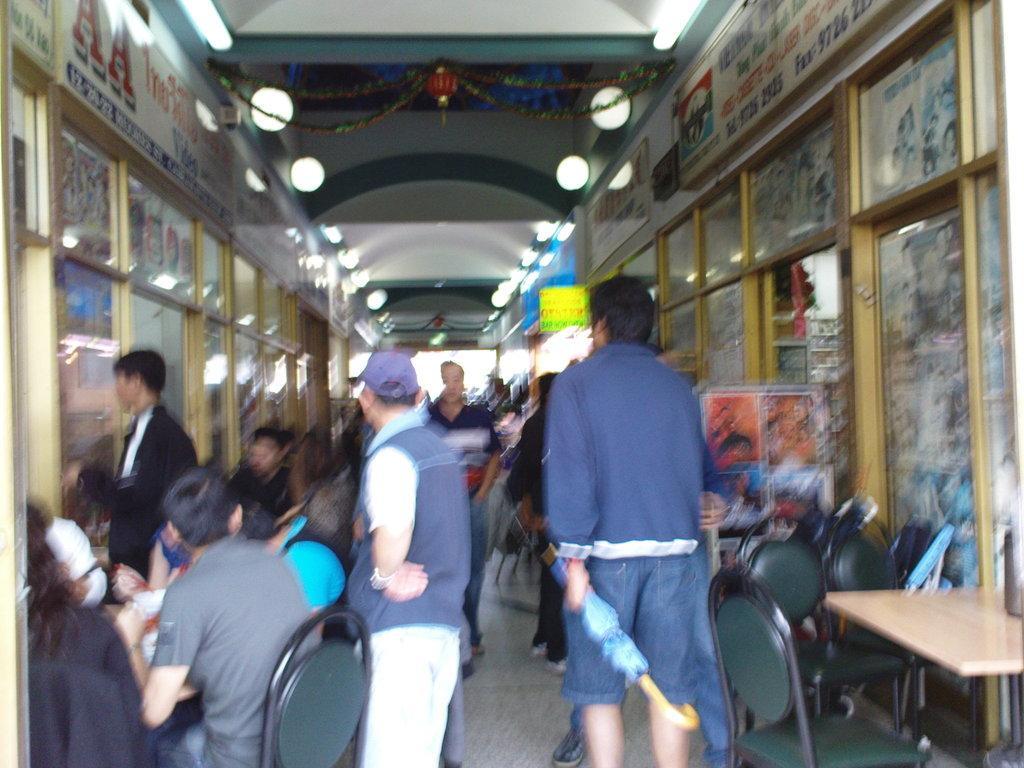In one or two sentences, can you explain what this image depicts? There is building with glass wall and stickers on it. There is a man sitting on chairs around the table and few men walking in the way. 